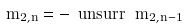Convert formula to latex. <formula><loc_0><loc_0><loc_500><loc_500>\ m _ { 2 , n } = - \ u n s u r r \, \ m _ { 2 , n - 1 }</formula> 